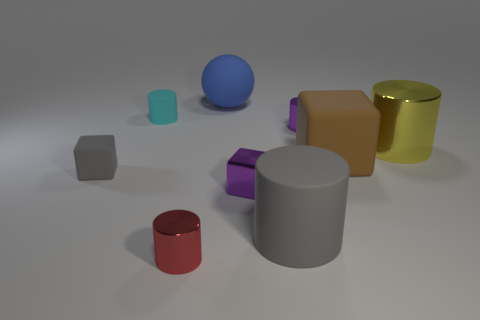Subtract all purple cylinders. How many cylinders are left? 4 Subtract all purple cylinders. How many cylinders are left? 4 Subtract all brown cylinders. Subtract all cyan cubes. How many cylinders are left? 5 Add 1 large blue rubber objects. How many objects exist? 10 Subtract all blocks. How many objects are left? 6 Add 4 matte things. How many matte things are left? 9 Add 7 large red cylinders. How many large red cylinders exist? 7 Subtract 0 cyan cubes. How many objects are left? 9 Subtract all purple cylinders. Subtract all red shiny objects. How many objects are left? 7 